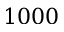<formula> <loc_0><loc_0><loc_500><loc_500>1 0 0 0</formula> 